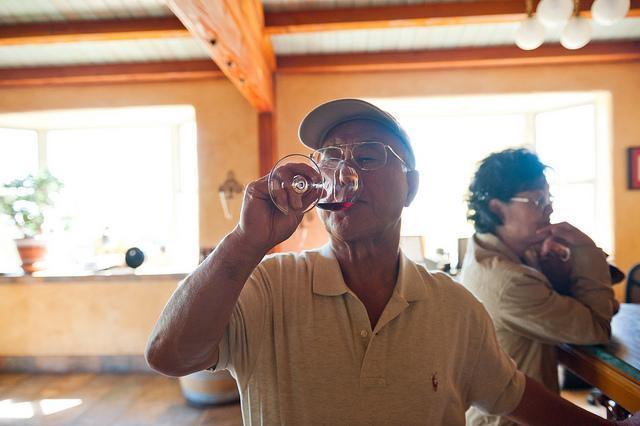How many wine glasses are visible?
Give a very brief answer. 1. How many people are there?
Give a very brief answer. 2. 